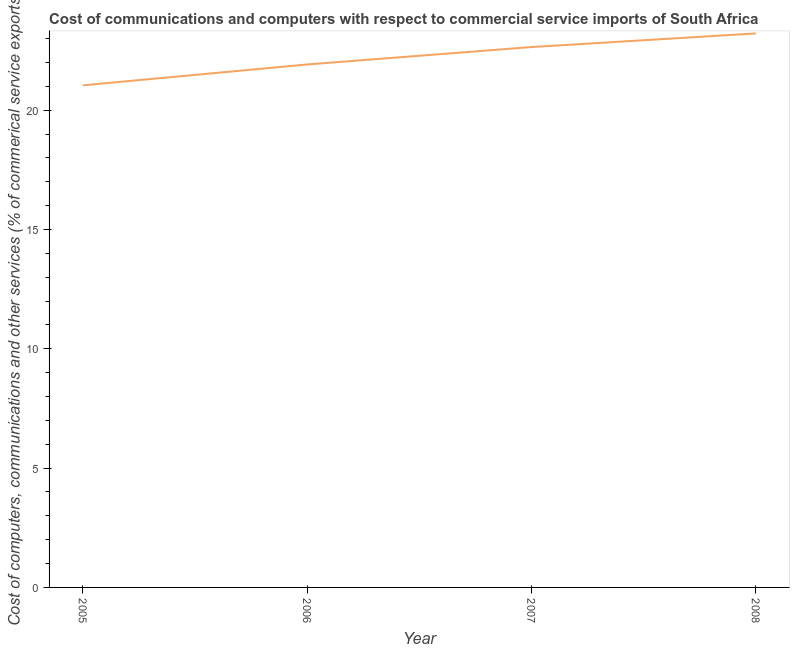What is the cost of communications in 2006?
Give a very brief answer. 21.92. Across all years, what is the maximum cost of communications?
Make the answer very short. 23.22. Across all years, what is the minimum cost of communications?
Provide a succinct answer. 21.04. In which year was the  computer and other services minimum?
Your answer should be very brief. 2005. What is the sum of the  computer and other services?
Provide a succinct answer. 88.82. What is the difference between the  computer and other services in 2005 and 2007?
Provide a short and direct response. -1.6. What is the average cost of communications per year?
Ensure brevity in your answer.  22.21. What is the median  computer and other services?
Your answer should be very brief. 22.28. Do a majority of the years between 2006 and 2005 (inclusive) have cost of communications greater than 21 %?
Provide a short and direct response. No. What is the ratio of the cost of communications in 2005 to that in 2007?
Provide a succinct answer. 0.93. Is the  computer and other services in 2006 less than that in 2008?
Provide a succinct answer. Yes. What is the difference between the highest and the second highest  computer and other services?
Your answer should be compact. 0.57. Is the sum of the cost of communications in 2007 and 2008 greater than the maximum cost of communications across all years?
Your answer should be very brief. Yes. What is the difference between the highest and the lowest  computer and other services?
Your response must be concise. 2.18. How many lines are there?
Your response must be concise. 1. How many years are there in the graph?
Provide a succinct answer. 4. Does the graph contain any zero values?
Provide a succinct answer. No. What is the title of the graph?
Ensure brevity in your answer.  Cost of communications and computers with respect to commercial service imports of South Africa. What is the label or title of the X-axis?
Offer a very short reply. Year. What is the label or title of the Y-axis?
Offer a very short reply. Cost of computers, communications and other services (% of commerical service exports). What is the Cost of computers, communications and other services (% of commerical service exports) in 2005?
Your answer should be very brief. 21.04. What is the Cost of computers, communications and other services (% of commerical service exports) of 2006?
Provide a succinct answer. 21.92. What is the Cost of computers, communications and other services (% of commerical service exports) in 2007?
Ensure brevity in your answer.  22.65. What is the Cost of computers, communications and other services (% of commerical service exports) in 2008?
Provide a succinct answer. 23.22. What is the difference between the Cost of computers, communications and other services (% of commerical service exports) in 2005 and 2006?
Keep it short and to the point. -0.87. What is the difference between the Cost of computers, communications and other services (% of commerical service exports) in 2005 and 2007?
Your answer should be very brief. -1.6. What is the difference between the Cost of computers, communications and other services (% of commerical service exports) in 2005 and 2008?
Your response must be concise. -2.18. What is the difference between the Cost of computers, communications and other services (% of commerical service exports) in 2006 and 2007?
Your response must be concise. -0.73. What is the difference between the Cost of computers, communications and other services (% of commerical service exports) in 2006 and 2008?
Ensure brevity in your answer.  -1.3. What is the difference between the Cost of computers, communications and other services (% of commerical service exports) in 2007 and 2008?
Your answer should be very brief. -0.57. What is the ratio of the Cost of computers, communications and other services (% of commerical service exports) in 2005 to that in 2006?
Your response must be concise. 0.96. What is the ratio of the Cost of computers, communications and other services (% of commerical service exports) in 2005 to that in 2007?
Give a very brief answer. 0.93. What is the ratio of the Cost of computers, communications and other services (% of commerical service exports) in 2005 to that in 2008?
Provide a short and direct response. 0.91. What is the ratio of the Cost of computers, communications and other services (% of commerical service exports) in 2006 to that in 2008?
Your response must be concise. 0.94. 